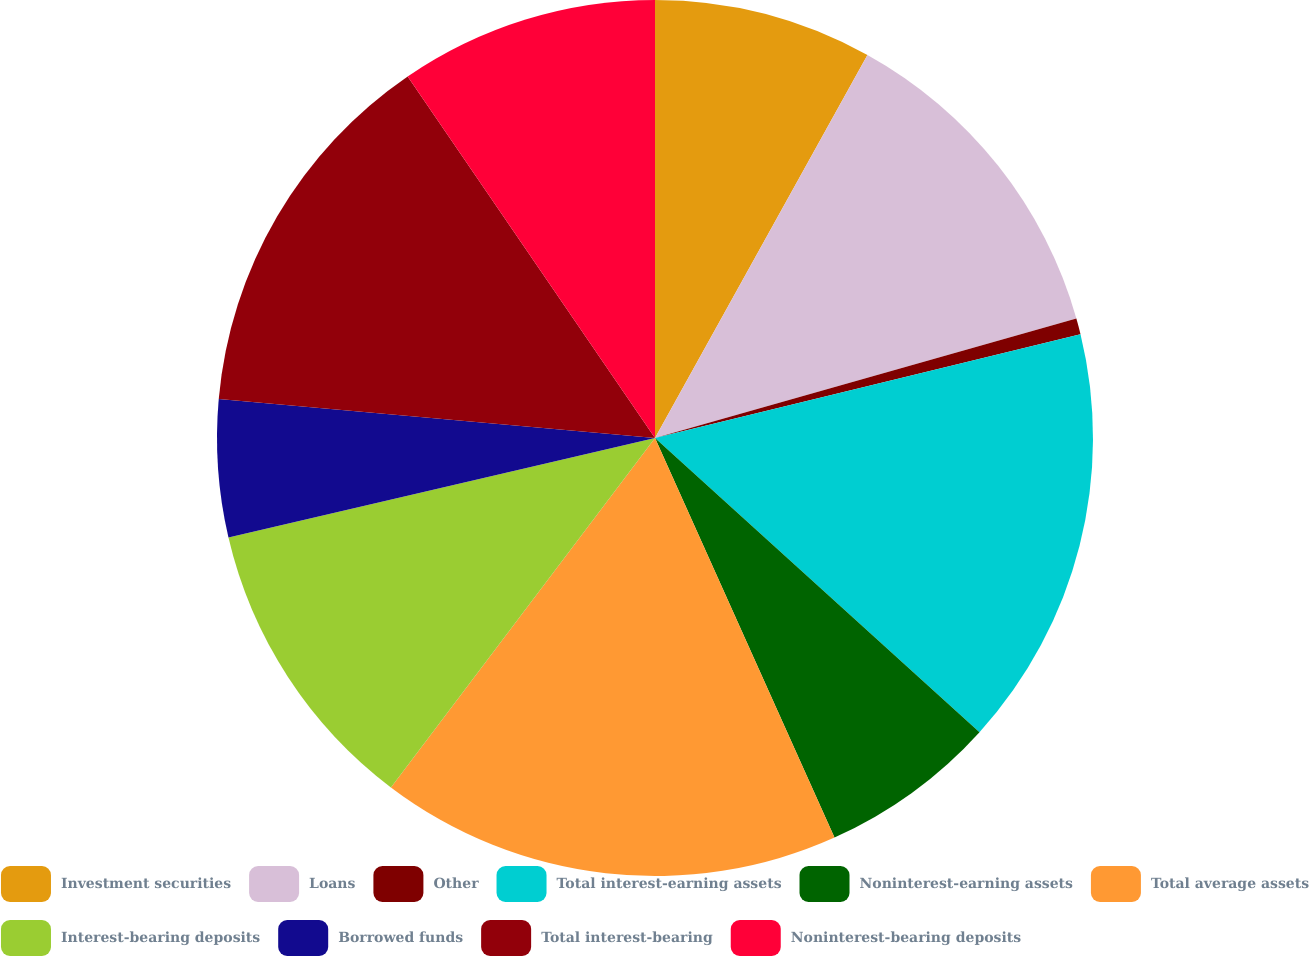Convert chart. <chart><loc_0><loc_0><loc_500><loc_500><pie_chart><fcel>Investment securities<fcel>Loans<fcel>Other<fcel>Total interest-earning assets<fcel>Noninterest-earning assets<fcel>Total average assets<fcel>Interest-bearing deposits<fcel>Borrowed funds<fcel>Total interest-bearing<fcel>Noninterest-bearing deposits<nl><fcel>8.06%<fcel>12.54%<fcel>0.59%<fcel>15.53%<fcel>6.56%<fcel>17.02%<fcel>11.05%<fcel>5.07%<fcel>14.03%<fcel>9.55%<nl></chart> 